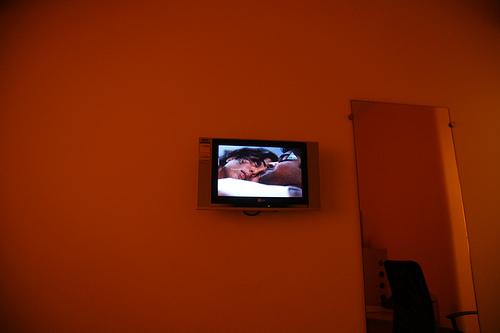Is the television on?
Quick response, please. Yes. Is the TV old?
Be succinct. No. Is the TV small?
Keep it brief. Yes. What is hanging on the wall?
Quick response, please. Tv. Is there a clock on the wall?
Keep it brief. No. Is the room cluttered?
Short answer required. No. Is there text shown on the monitor screen?
Quick response, please. No. What is glowing?
Keep it brief. Television. What are the bright things?
Answer briefly. Tv. Is the TV mounted on the wall?
Write a very short answer. Yes. What color is the wall?
Give a very brief answer. Orange. Is the room well lit?
Short answer required. No. Is the man on TV wearing a tie?
Quick response, please. No. What is on the wall?
Give a very brief answer. Television. Is there a phone in the picture?
Answer briefly. No. 